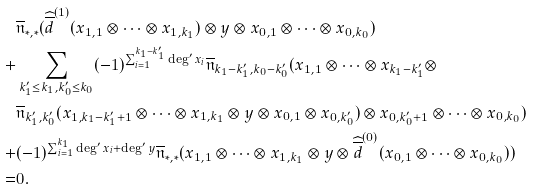Convert formula to latex. <formula><loc_0><loc_0><loc_500><loc_500>& \overline { \mathfrak n } _ { * , * } ( \widehat { \overline { d } } ^ { ( 1 ) } ( x _ { 1 , 1 } \otimes \dots \otimes x _ { 1 , k _ { 1 } } ) \otimes y \otimes x _ { 0 , 1 } \otimes \dots \otimes x _ { 0 , k _ { 0 } } ) \\ + & \sum _ { k ^ { \prime } _ { 1 } \leq k _ { 1 } , k ^ { \prime } _ { 0 } \leq k _ { 0 } } ( - 1 ) ^ { \sum _ { i = 1 } ^ { k _ { 1 } - k ^ { \prime } _ { 1 } } \deg ^ { \prime } x _ { i } } \overline { \mathfrak n } _ { k _ { 1 } - k ^ { \prime } _ { 1 } , k _ { 0 } - k ^ { \prime } _ { 0 } } ( x _ { 1 , 1 } \otimes \dots \otimes x _ { k _ { 1 } - k ^ { \prime } _ { 1 } } \otimes \\ & \overline { \mathfrak n } _ { k ^ { \prime } _ { 1 } , k ^ { \prime } _ { 0 } } ( x _ { 1 , k _ { 1 } - k ^ { \prime } _ { 1 } + 1 } \otimes \dots \otimes x _ { 1 , k _ { 1 } } \otimes y \otimes x _ { 0 , 1 } \otimes x _ { 0 , k ^ { \prime } _ { 0 } } ) \otimes x _ { 0 , k ^ { \prime } _ { 0 } + 1 } \otimes \dots \otimes x _ { 0 , k _ { 0 } } ) \\ + & ( - 1 ) ^ { \sum _ { i = 1 } ^ { k _ { 1 } } \deg ^ { \prime } x _ { i } + \deg ^ { \prime } y } \overline { \mathfrak n } _ { * , * } ( x _ { 1 , 1 } \otimes \dots \otimes x _ { 1 , k _ { 1 } } \otimes y \otimes \widehat { \overline { d } } ^ { ( 0 ) } ( x _ { 0 , 1 } \otimes \dots \otimes x _ { 0 , k _ { 0 } } ) ) \\ = & 0 .</formula> 